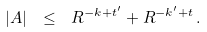<formula> <loc_0><loc_0><loc_500><loc_500>| A | \ \leq \ R ^ { - k + t ^ { \prime } } + R ^ { - k ^ { \prime } + t } \, .</formula> 